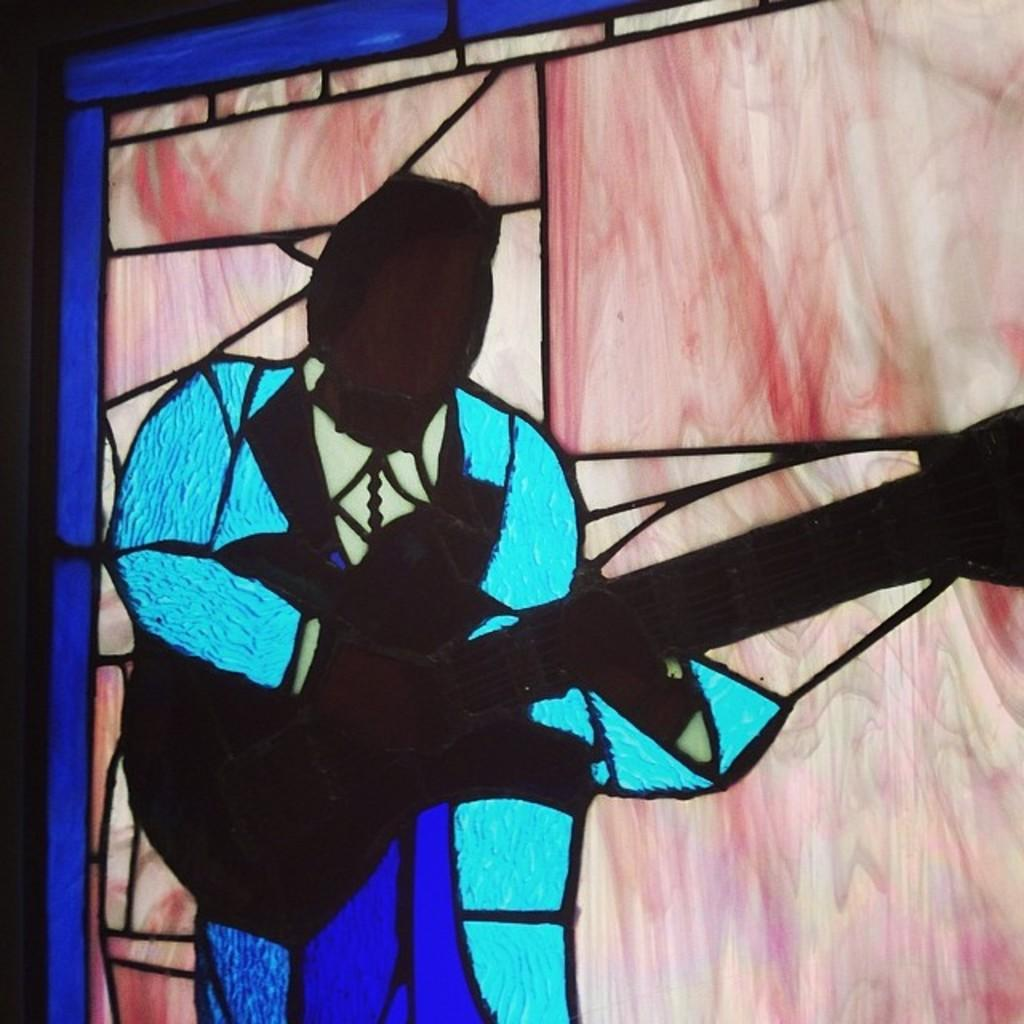What type of artwork is featured in the image? There is a stained glass in the image. What is the subject matter of the stained glass? The stained glass depicts a human figure holding a guitar. What colors can be seen in the stained glass? The colors blue, black, and pink are present in the image. What type of rice is being cooked in the image? There is no rice present in the image; it features a stained glass with a human figure holding a guitar. What type of instrument is being played in the image? The image depicts a human figure holding a guitar, but it does not show the guitar being played. 